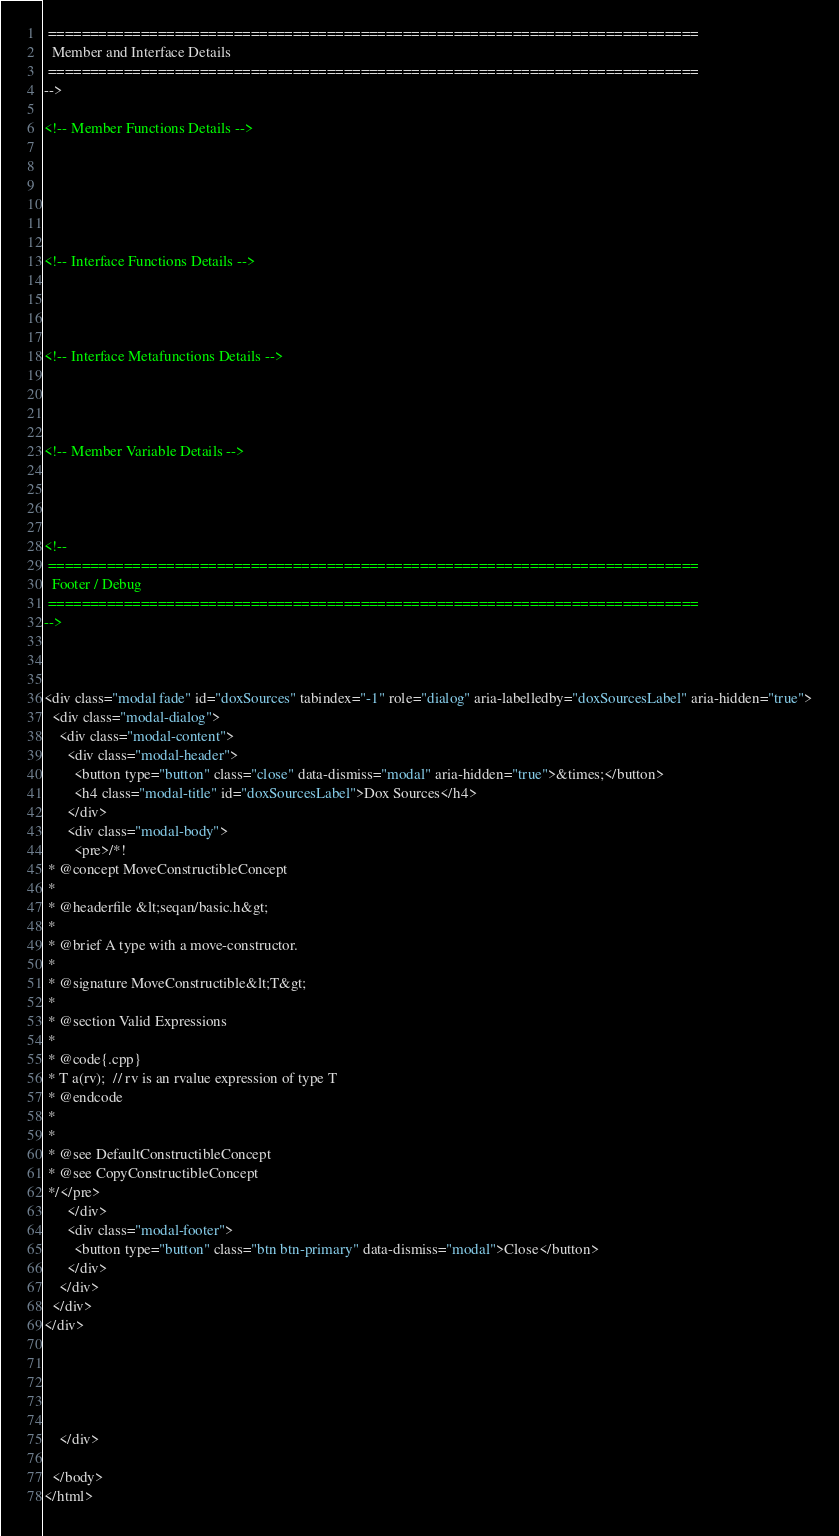Convert code to text. <code><loc_0><loc_0><loc_500><loc_500><_HTML_> =============================================================================
  Member and Interface Details
 =============================================================================
-->

<!-- Member Functions Details -->






<!-- Interface Functions Details -->




<!-- Interface Metafunctions Details -->




<!-- Member Variable Details -->




<!--
 =============================================================================
  Footer / Debug
 =============================================================================
-->



<div class="modal fade" id="doxSources" tabindex="-1" role="dialog" aria-labelledby="doxSourcesLabel" aria-hidden="true">
  <div class="modal-dialog">
    <div class="modal-content">
      <div class="modal-header">
        <button type="button" class="close" data-dismiss="modal" aria-hidden="true">&times;</button>
        <h4 class="modal-title" id="doxSourcesLabel">Dox Sources</h4>
      </div>
      <div class="modal-body">
        <pre>/*!
 * @concept MoveConstructibleConcept
 * 
 * @headerfile &lt;seqan/basic.h&gt;
 * 
 * @brief A type with a move-constructor.
 * 
 * @signature MoveConstructible&lt;T&gt;
 * 
 * @section Valid Expressions
 * 
 * @code{.cpp}
 * T a(rv);  // rv is an rvalue expression of type T
 * @endcode
 * 
 * 
 * @see DefaultConstructibleConcept
 * @see CopyConstructibleConcept
 */</pre>
      </div>
      <div class="modal-footer">
        <button type="button" class="btn btn-primary" data-dismiss="modal">Close</button>
      </div>
    </div>
  </div>
</div>





    </div>

  </body>
</html></code> 